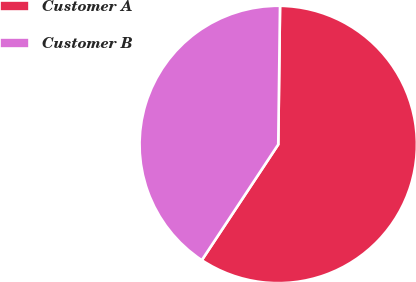Convert chart to OTSL. <chart><loc_0><loc_0><loc_500><loc_500><pie_chart><fcel>Customer A<fcel>Customer B<nl><fcel>59.09%<fcel>40.91%<nl></chart> 